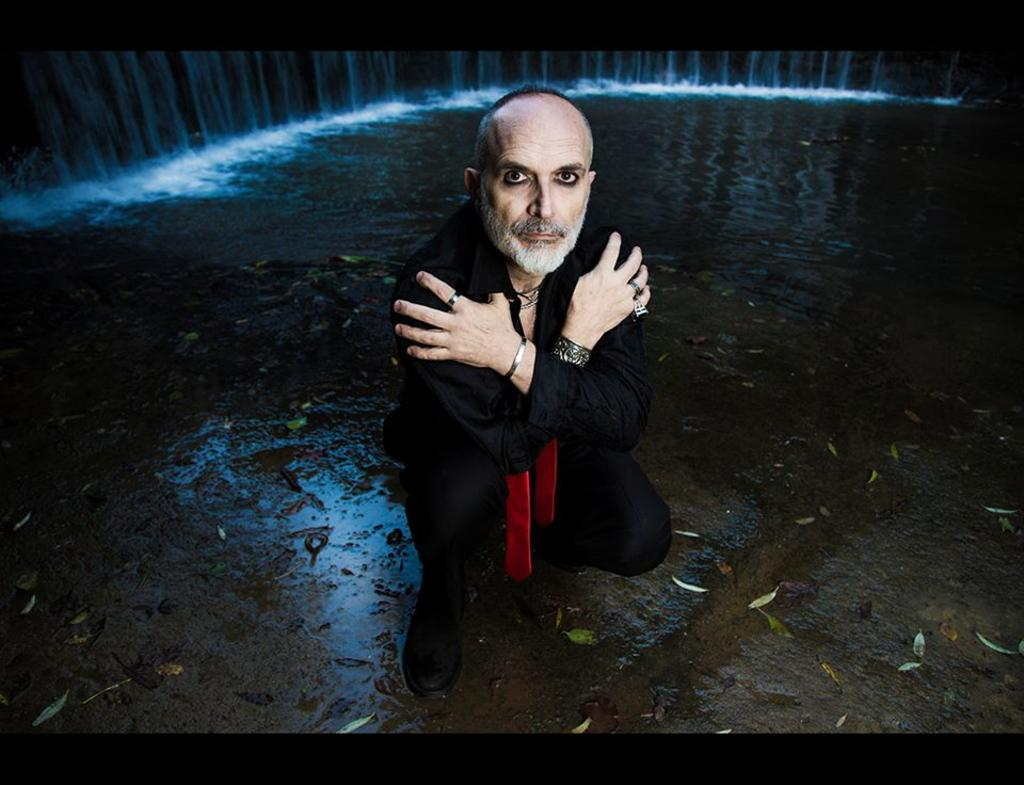Who is in the image? There is a man in the image. What is the man wearing? The man is wearing a black shirt. What is the man's position in the image? The man is sitting on the ground. What is the man doing in the image? The man is looking at the camera. What natural elements can be seen in the image? There is lake water and a small waterfall visible in the image. What type of lead can be seen in the man's eyes in the image? There is no mention of lead or any reference to the man's eyes in the provided facts, so we cannot answer this question. 